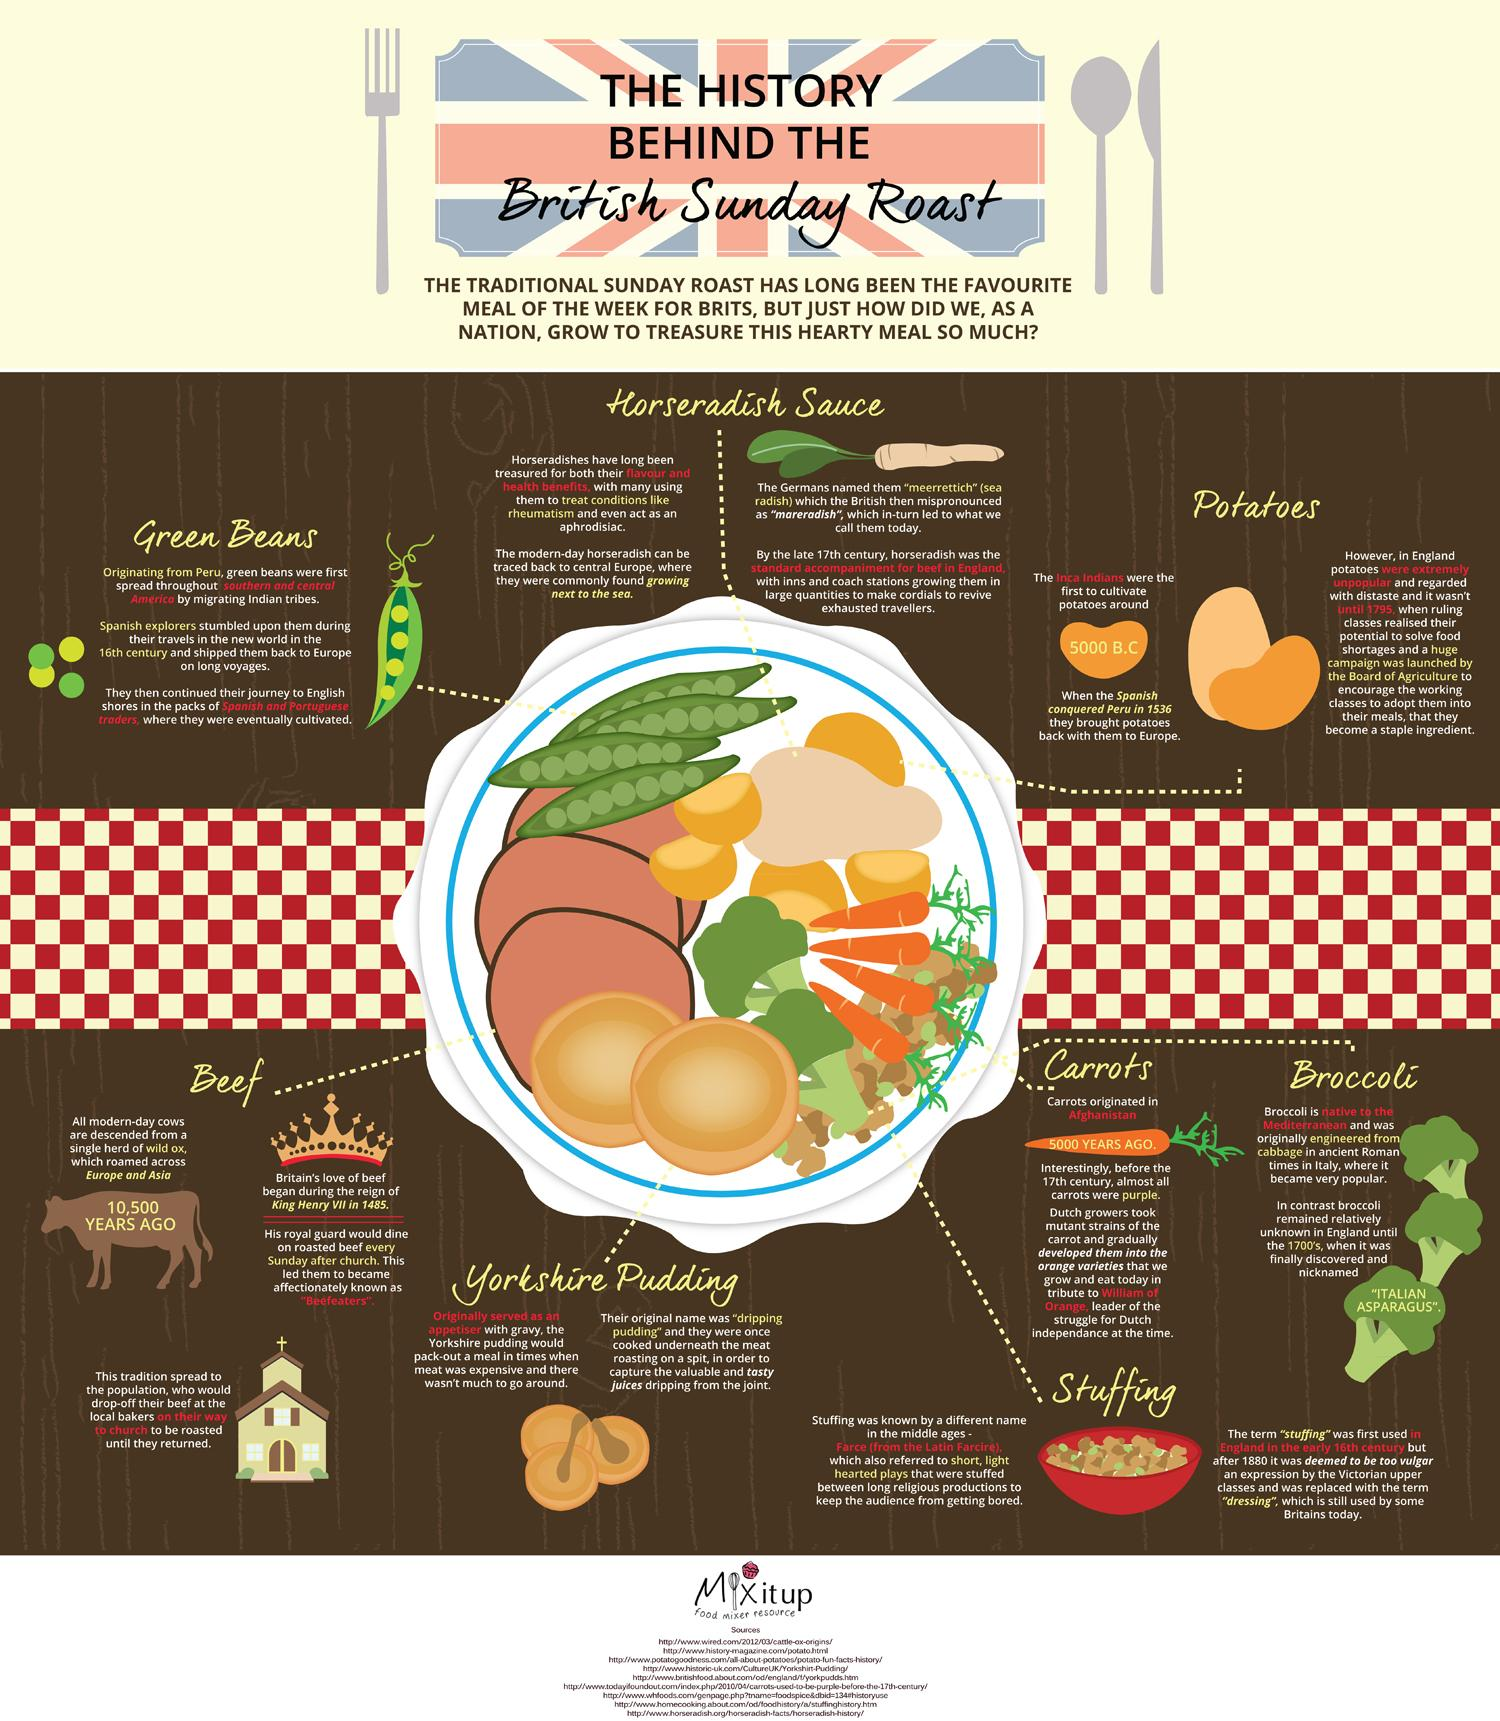Draw attention to some important aspects in this diagram. The original name of Yorkshire pudding is "dripping pudding. It is a well-known fact that when broccoli was first introduced in England in the mid 18th century, it was commonly referred to as "Italian Asparagus. 